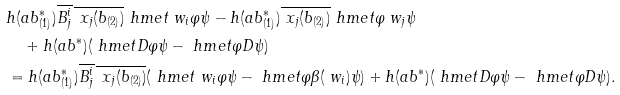<formula> <loc_0><loc_0><loc_500><loc_500>& h ( a b ^ { * } _ { ( 1 ) } ) \overline { B ^ { i } _ { j } } \, \overline { \ x _ { j } ( b _ { ( 2 ) } ) } \ h m e t { \ w _ { i } \varphi } { \psi } - h ( a b ^ { * } _ { ( 1 ) } ) \overline { \ x _ { j } ( b _ { ( 2 ) } ) } \ h m e t { \varphi } { \ w _ { j } \psi } \\ & \quad + h ( a b ^ { * } ) ( \ h m e t { D \varphi } { \psi } - \ h m e t { \varphi } { D \psi } ) \\ & = h ( a b ^ { * } _ { ( 1 ) } ) \overline { B ^ { i } _ { j } } \, \overline { \ x _ { j } ( b _ { ( 2 ) } ) } ( \ h m e t { \ w _ { i } \varphi } { \psi } - \ h m e t { \varphi } { \beta ( \ w _ { i } ) \psi } ) + h ( a b ^ { * } ) ( \ h m e t { D \varphi } { \psi } - \ h m e t { \varphi } { D \psi } ) .</formula> 